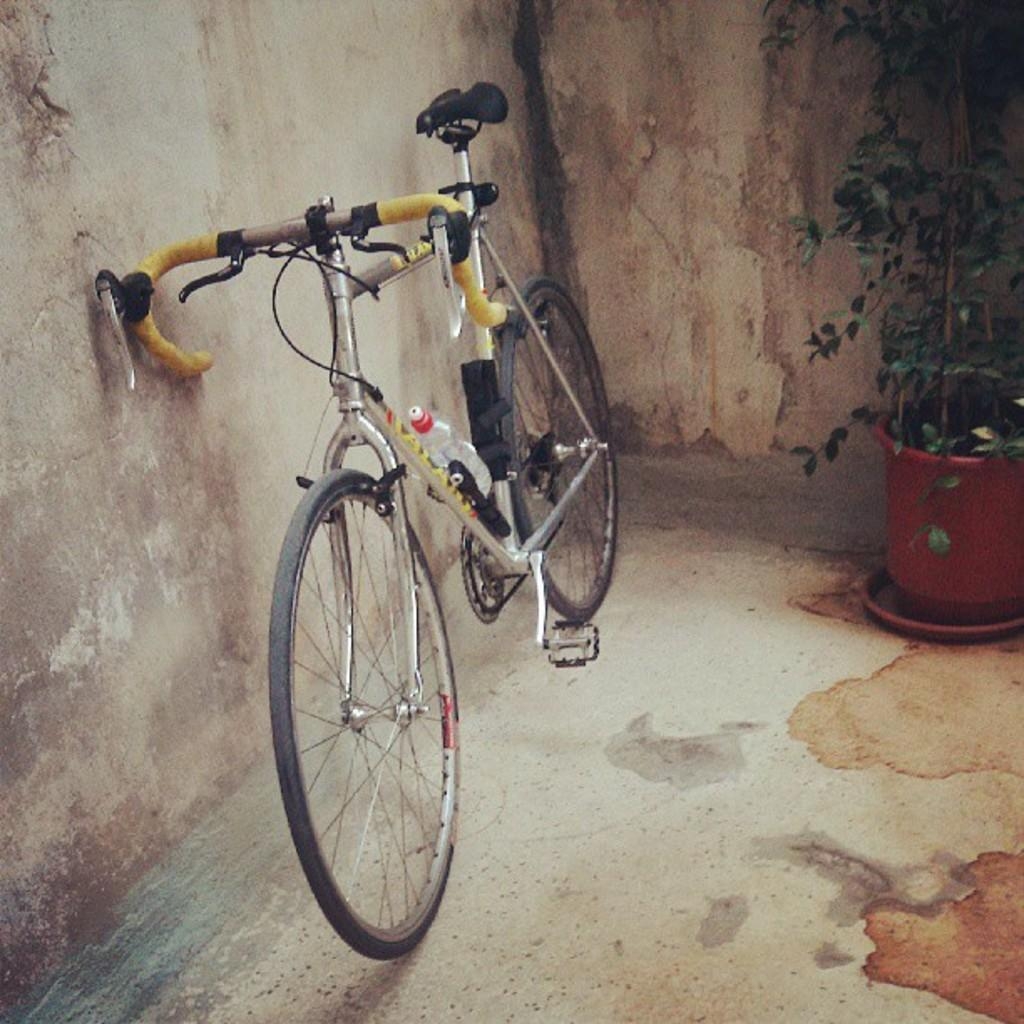What is the main object in the image? There is a bicycle in the image. What else can be seen in the image besides the bicycle? There is a flower pot in the image. Can you describe the color of the wall in the image? The wall in the image has a cream and brown color. What type of music is the band playing in the image? There is no band present in the image, so it is not possible to determine what type of music they might be playing. 